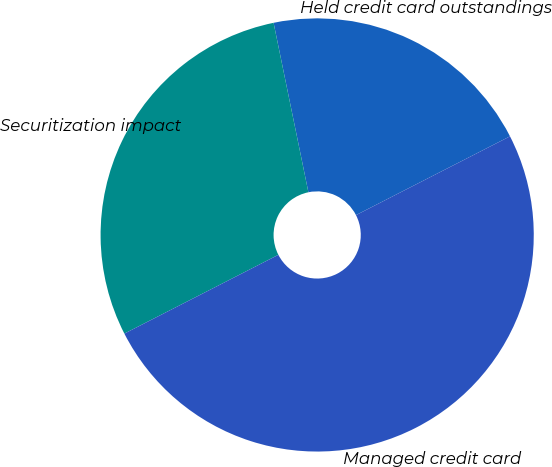Convert chart to OTSL. <chart><loc_0><loc_0><loc_500><loc_500><pie_chart><fcel>Held credit card outstandings<fcel>Securitization impact<fcel>Managed credit card<nl><fcel>20.7%<fcel>29.3%<fcel>50.0%<nl></chart> 